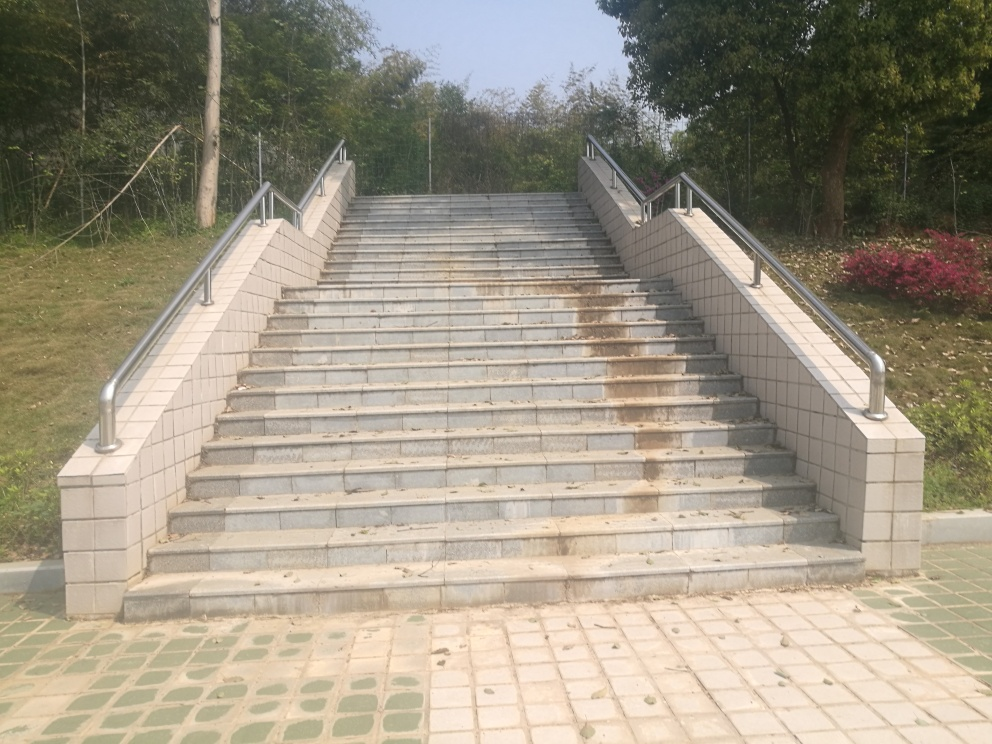What is the overall clarity of the image? The overall clarity of the image is good. The elements within the photo, such as the staircase, handrails, and surrounding vegetation are in focus, and details can be discerned without difficulty. However, it would benefit from a slight boost in contrast to make the features stand out more vividly. 